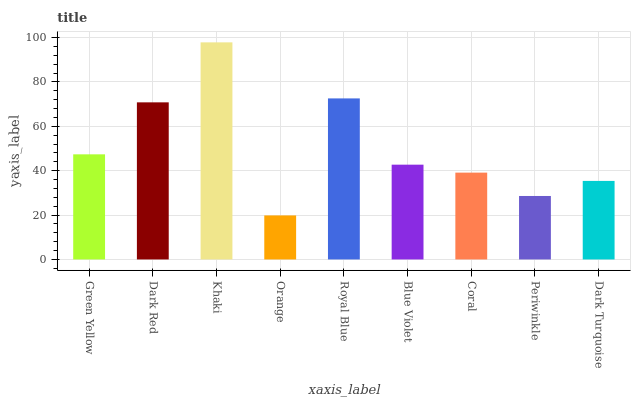Is Dark Red the minimum?
Answer yes or no. No. Is Dark Red the maximum?
Answer yes or no. No. Is Dark Red greater than Green Yellow?
Answer yes or no. Yes. Is Green Yellow less than Dark Red?
Answer yes or no. Yes. Is Green Yellow greater than Dark Red?
Answer yes or no. No. Is Dark Red less than Green Yellow?
Answer yes or no. No. Is Blue Violet the high median?
Answer yes or no. Yes. Is Blue Violet the low median?
Answer yes or no. Yes. Is Dark Turquoise the high median?
Answer yes or no. No. Is Green Yellow the low median?
Answer yes or no. No. 